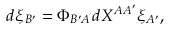Convert formula to latex. <formula><loc_0><loc_0><loc_500><loc_500>d \xi _ { B ^ { \prime } } = \Phi _ { B ^ { \prime } A } d X ^ { A A ^ { \prime } } \xi _ { A ^ { \prime } } ,</formula> 